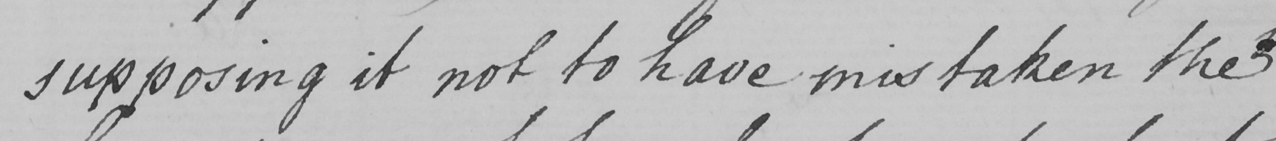What text is written in this handwritten line? supposing it not to have mistaken the 